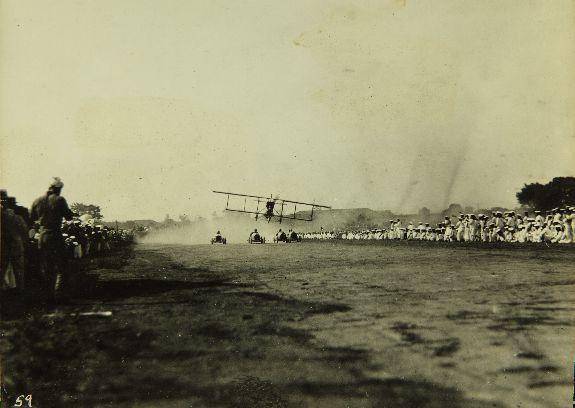How many people are in the photo?
Give a very brief answer. 2. 